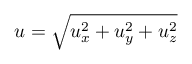<formula> <loc_0><loc_0><loc_500><loc_500>u = \sqrt { u _ { x } ^ { 2 } + u _ { y } ^ { 2 } + u _ { z } ^ { 2 } }</formula> 